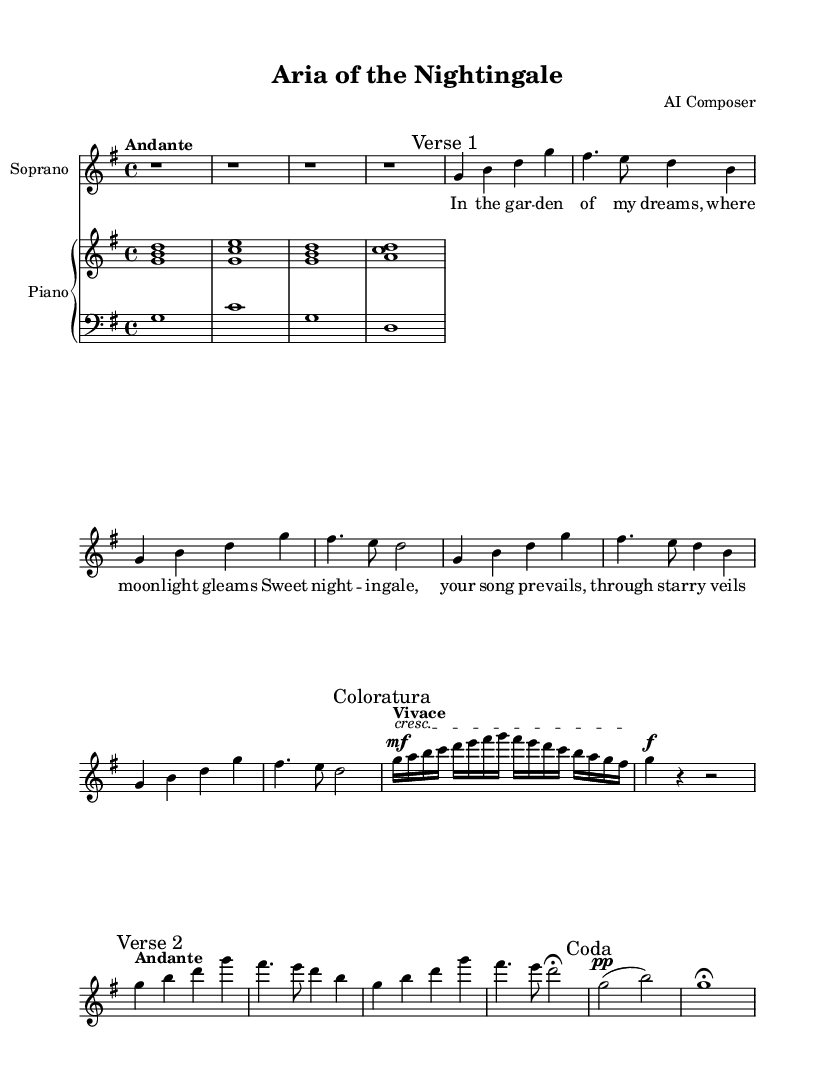What is the key signature of this music? The key signature indicates that the music is in G major, which has one sharp (F#). This is visible at the beginning of the staff where the key signature is indicated.
Answer: G major What is the time signature of this piece? The time signature is shown at the beginning of the music, which indicates how many beats are in each measure. In this piece, it is 4/4, meaning there are four beats per measure.
Answer: 4/4 What tempo marking is given for the introduction? The tempo marking "Andante" signifies a moderate walking pace for the introduction section. This is indicated at the beginning of the global settings in the score.
Answer: Andante How many measures are in the coloratura section? The coloratura section starts with a marked "Coloratura" and contains a specific rhythmic pattern with the high-speed notes. Count each measure in the section, and there are 2 measures in total.
Answer: 2 What dynamic indication is specified for the coloratura section? In this section, the music specifies a dynamic of "mf" (mezzo forte) at the start of the coloratura line and transitions to a piano marking afterward. This provides guidance on the volume level for that section.
Answer: mf How many verses are present in the sheet music? The sheet music contains two main sections labeled as "Verse 1" and "Verse 2." Each of these verses has distinct melodic phrases, indicating the presence of two verses in this piece.
Answer: 2 What is the marked dynamic at the end of the piece? The coda section closes with a dynamic indication of "pp" (pianississimo), which denotes a very soft sound before finishing with a fermata on the final note. This dynamic marking is important for expressing the conclusion.
Answer: pp 